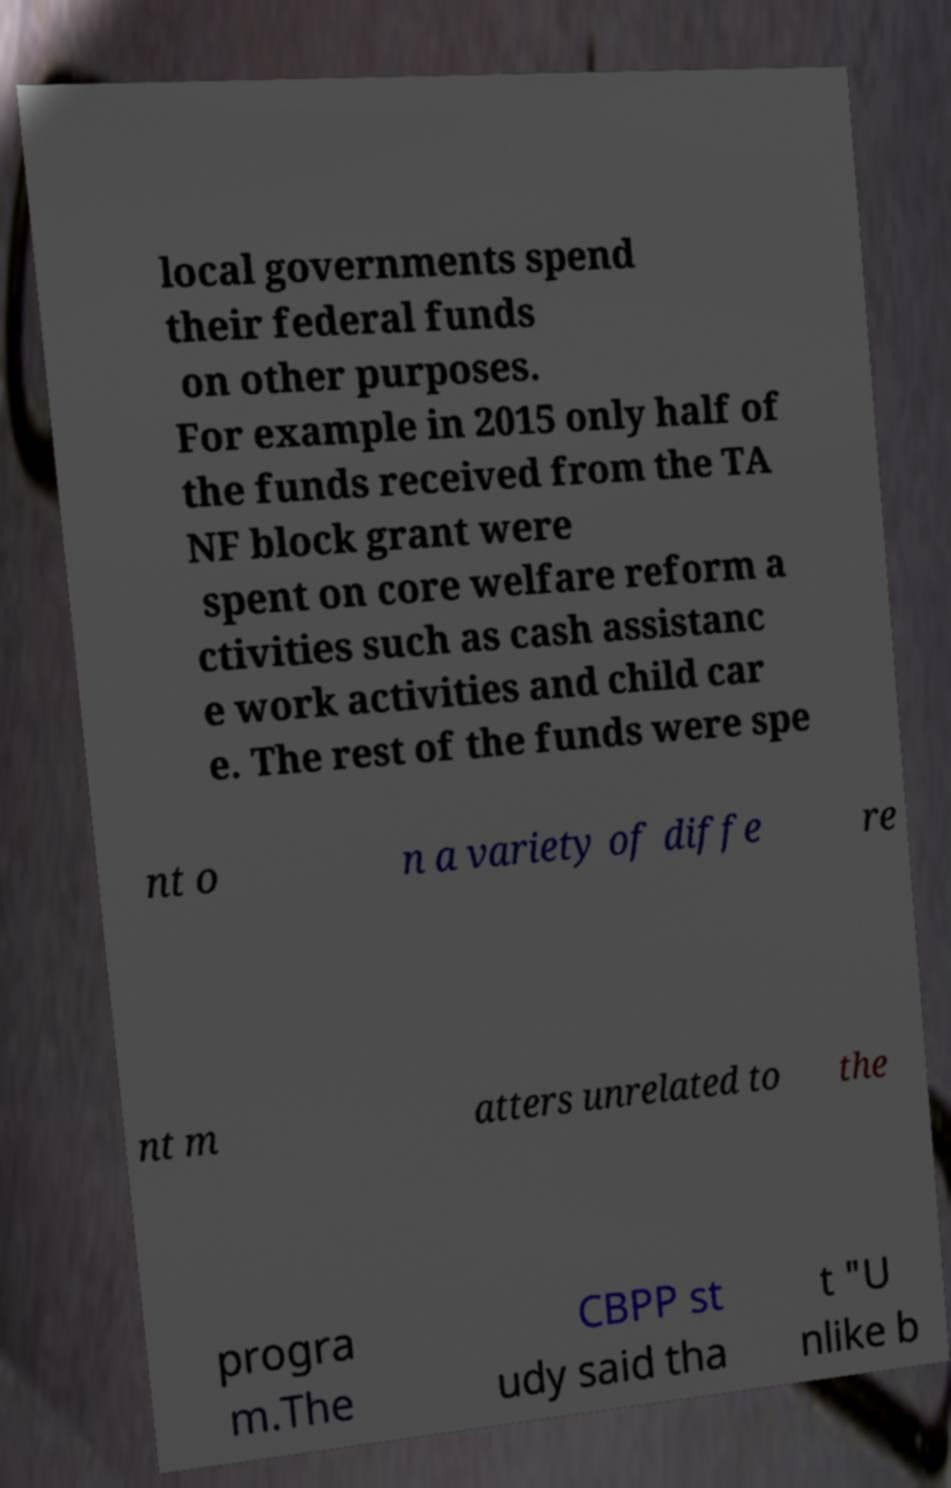There's text embedded in this image that I need extracted. Can you transcribe it verbatim? local governments spend their federal funds on other purposes. For example in 2015 only half of the funds received from the TA NF block grant were spent on core welfare reform a ctivities such as cash assistanc e work activities and child car e. The rest of the funds were spe nt o n a variety of diffe re nt m atters unrelated to the progra m.The CBPP st udy said tha t "U nlike b 